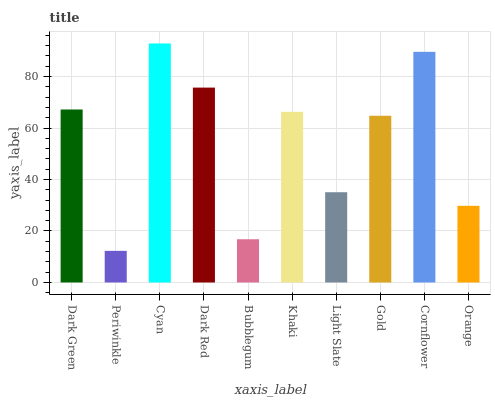Is Periwinkle the minimum?
Answer yes or no. Yes. Is Cyan the maximum?
Answer yes or no. Yes. Is Cyan the minimum?
Answer yes or no. No. Is Periwinkle the maximum?
Answer yes or no. No. Is Cyan greater than Periwinkle?
Answer yes or no. Yes. Is Periwinkle less than Cyan?
Answer yes or no. Yes. Is Periwinkle greater than Cyan?
Answer yes or no. No. Is Cyan less than Periwinkle?
Answer yes or no. No. Is Khaki the high median?
Answer yes or no. Yes. Is Gold the low median?
Answer yes or no. Yes. Is Gold the high median?
Answer yes or no. No. Is Bubblegum the low median?
Answer yes or no. No. 